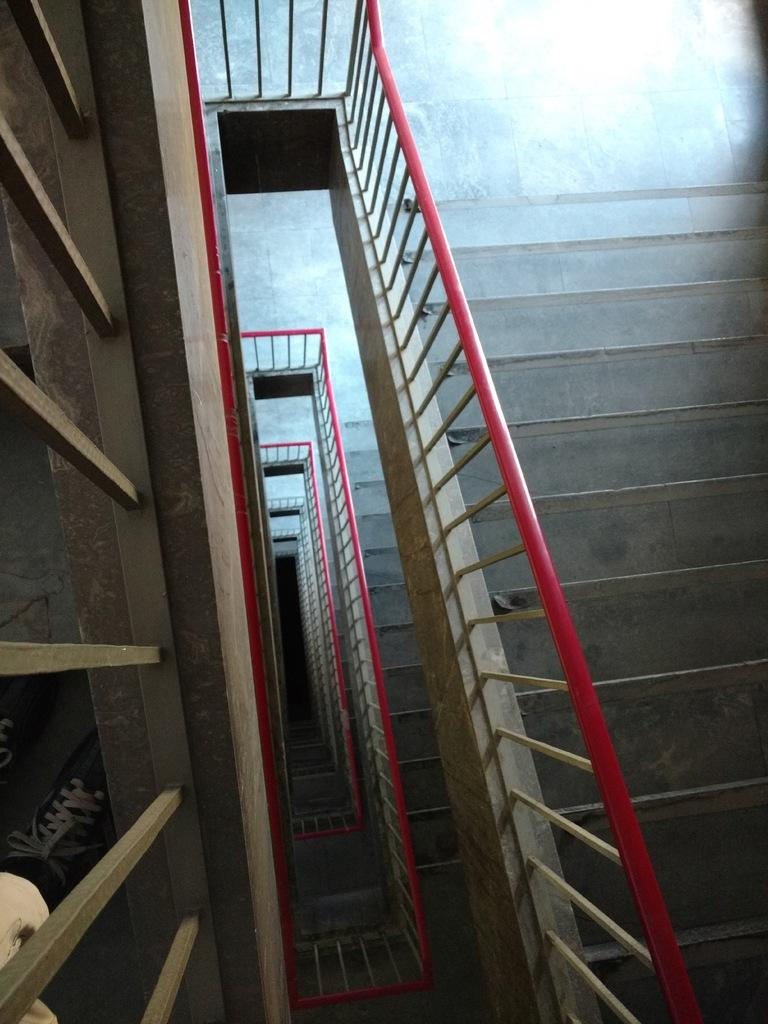What type of structure is present in the image? There are staircases visible in the building. What can be seen on the left side of the image? There is a fence on the left side of the image. What is located behind the fence? Shoes are visible behind the fence. What type of competition is taking place in the image? There is no competition present in the image; it only shows a building with staircases, a fence, and shoes behind the fence. 